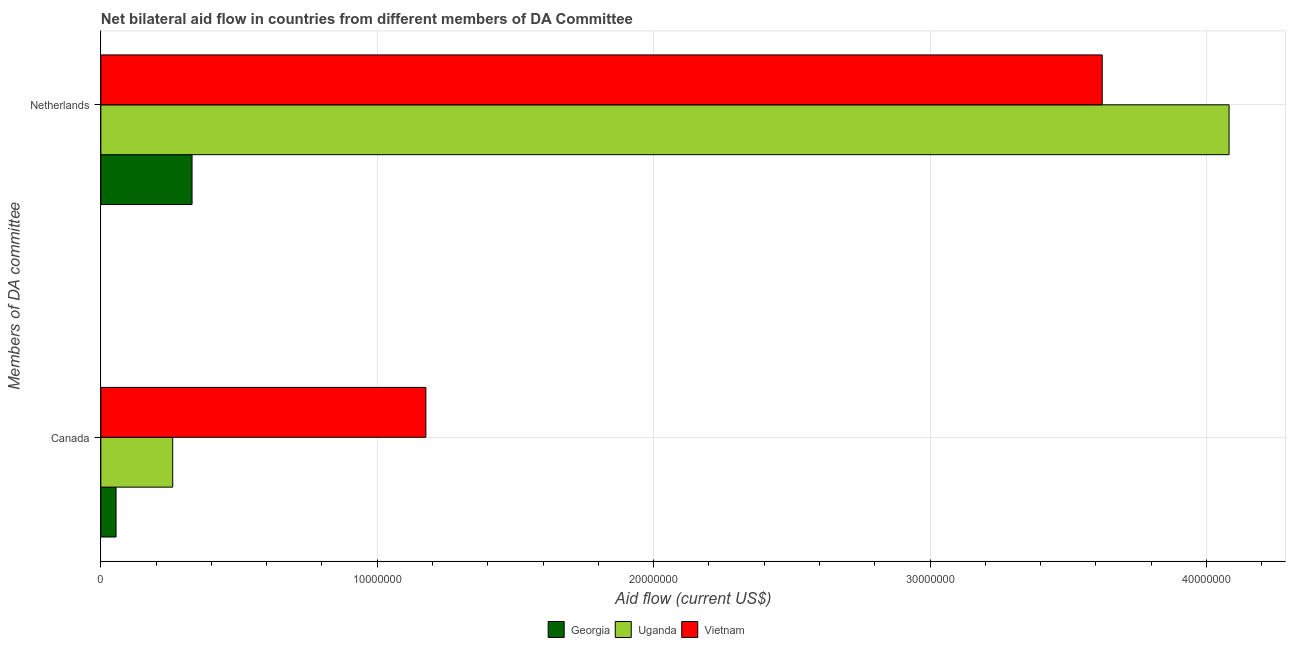How many groups of bars are there?
Your answer should be very brief. 2. Are the number of bars per tick equal to the number of legend labels?
Your answer should be compact. Yes. How many bars are there on the 2nd tick from the top?
Ensure brevity in your answer.  3. What is the label of the 2nd group of bars from the top?
Provide a short and direct response. Canada. What is the amount of aid given by canada in Georgia?
Ensure brevity in your answer.  5.50e+05. Across all countries, what is the maximum amount of aid given by netherlands?
Offer a terse response. 4.08e+07. Across all countries, what is the minimum amount of aid given by canada?
Your response must be concise. 5.50e+05. In which country was the amount of aid given by canada maximum?
Keep it short and to the point. Vietnam. In which country was the amount of aid given by netherlands minimum?
Keep it short and to the point. Georgia. What is the total amount of aid given by netherlands in the graph?
Make the answer very short. 8.04e+07. What is the difference between the amount of aid given by canada in Uganda and that in Vietnam?
Your response must be concise. -9.16e+06. What is the difference between the amount of aid given by canada in Georgia and the amount of aid given by netherlands in Uganda?
Provide a succinct answer. -4.03e+07. What is the average amount of aid given by netherlands per country?
Offer a very short reply. 2.68e+07. What is the difference between the amount of aid given by canada and amount of aid given by netherlands in Vietnam?
Give a very brief answer. -2.45e+07. In how many countries, is the amount of aid given by canada greater than 32000000 US$?
Your answer should be very brief. 0. What is the ratio of the amount of aid given by canada in Vietnam to that in Georgia?
Offer a terse response. 21.38. Is the amount of aid given by canada in Georgia less than that in Vietnam?
Give a very brief answer. Yes. What does the 3rd bar from the top in Canada represents?
Offer a terse response. Georgia. What does the 2nd bar from the bottom in Netherlands represents?
Keep it short and to the point. Uganda. Are all the bars in the graph horizontal?
Your answer should be compact. Yes. What is the difference between two consecutive major ticks on the X-axis?
Your answer should be very brief. 1.00e+07. Are the values on the major ticks of X-axis written in scientific E-notation?
Ensure brevity in your answer.  No. Does the graph contain grids?
Your answer should be very brief. Yes. How are the legend labels stacked?
Make the answer very short. Horizontal. What is the title of the graph?
Give a very brief answer. Net bilateral aid flow in countries from different members of DA Committee. What is the label or title of the Y-axis?
Your response must be concise. Members of DA committee. What is the Aid flow (current US$) of Uganda in Canada?
Give a very brief answer. 2.60e+06. What is the Aid flow (current US$) in Vietnam in Canada?
Your answer should be very brief. 1.18e+07. What is the Aid flow (current US$) of Georgia in Netherlands?
Ensure brevity in your answer.  3.30e+06. What is the Aid flow (current US$) in Uganda in Netherlands?
Give a very brief answer. 4.08e+07. What is the Aid flow (current US$) of Vietnam in Netherlands?
Your answer should be compact. 3.62e+07. Across all Members of DA committee, what is the maximum Aid flow (current US$) of Georgia?
Offer a very short reply. 3.30e+06. Across all Members of DA committee, what is the maximum Aid flow (current US$) in Uganda?
Give a very brief answer. 4.08e+07. Across all Members of DA committee, what is the maximum Aid flow (current US$) in Vietnam?
Provide a short and direct response. 3.62e+07. Across all Members of DA committee, what is the minimum Aid flow (current US$) of Georgia?
Provide a short and direct response. 5.50e+05. Across all Members of DA committee, what is the minimum Aid flow (current US$) of Uganda?
Provide a short and direct response. 2.60e+06. Across all Members of DA committee, what is the minimum Aid flow (current US$) of Vietnam?
Make the answer very short. 1.18e+07. What is the total Aid flow (current US$) in Georgia in the graph?
Give a very brief answer. 3.85e+06. What is the total Aid flow (current US$) of Uganda in the graph?
Provide a short and direct response. 4.34e+07. What is the total Aid flow (current US$) in Vietnam in the graph?
Offer a very short reply. 4.80e+07. What is the difference between the Aid flow (current US$) in Georgia in Canada and that in Netherlands?
Offer a terse response. -2.75e+06. What is the difference between the Aid flow (current US$) of Uganda in Canada and that in Netherlands?
Keep it short and to the point. -3.82e+07. What is the difference between the Aid flow (current US$) in Vietnam in Canada and that in Netherlands?
Your answer should be compact. -2.45e+07. What is the difference between the Aid flow (current US$) of Georgia in Canada and the Aid flow (current US$) of Uganda in Netherlands?
Offer a terse response. -4.03e+07. What is the difference between the Aid flow (current US$) in Georgia in Canada and the Aid flow (current US$) in Vietnam in Netherlands?
Ensure brevity in your answer.  -3.57e+07. What is the difference between the Aid flow (current US$) in Uganda in Canada and the Aid flow (current US$) in Vietnam in Netherlands?
Offer a terse response. -3.36e+07. What is the average Aid flow (current US$) of Georgia per Members of DA committee?
Your response must be concise. 1.92e+06. What is the average Aid flow (current US$) in Uganda per Members of DA committee?
Offer a terse response. 2.17e+07. What is the average Aid flow (current US$) of Vietnam per Members of DA committee?
Your answer should be very brief. 2.40e+07. What is the difference between the Aid flow (current US$) of Georgia and Aid flow (current US$) of Uganda in Canada?
Provide a succinct answer. -2.05e+06. What is the difference between the Aid flow (current US$) of Georgia and Aid flow (current US$) of Vietnam in Canada?
Ensure brevity in your answer.  -1.12e+07. What is the difference between the Aid flow (current US$) of Uganda and Aid flow (current US$) of Vietnam in Canada?
Ensure brevity in your answer.  -9.16e+06. What is the difference between the Aid flow (current US$) of Georgia and Aid flow (current US$) of Uganda in Netherlands?
Provide a succinct answer. -3.75e+07. What is the difference between the Aid flow (current US$) in Georgia and Aid flow (current US$) in Vietnam in Netherlands?
Keep it short and to the point. -3.29e+07. What is the difference between the Aid flow (current US$) in Uganda and Aid flow (current US$) in Vietnam in Netherlands?
Keep it short and to the point. 4.59e+06. What is the ratio of the Aid flow (current US$) of Georgia in Canada to that in Netherlands?
Your response must be concise. 0.17. What is the ratio of the Aid flow (current US$) of Uganda in Canada to that in Netherlands?
Your answer should be compact. 0.06. What is the ratio of the Aid flow (current US$) of Vietnam in Canada to that in Netherlands?
Offer a very short reply. 0.32. What is the difference between the highest and the second highest Aid flow (current US$) of Georgia?
Your answer should be compact. 2.75e+06. What is the difference between the highest and the second highest Aid flow (current US$) in Uganda?
Offer a very short reply. 3.82e+07. What is the difference between the highest and the second highest Aid flow (current US$) in Vietnam?
Make the answer very short. 2.45e+07. What is the difference between the highest and the lowest Aid flow (current US$) of Georgia?
Your answer should be very brief. 2.75e+06. What is the difference between the highest and the lowest Aid flow (current US$) in Uganda?
Provide a succinct answer. 3.82e+07. What is the difference between the highest and the lowest Aid flow (current US$) of Vietnam?
Offer a terse response. 2.45e+07. 